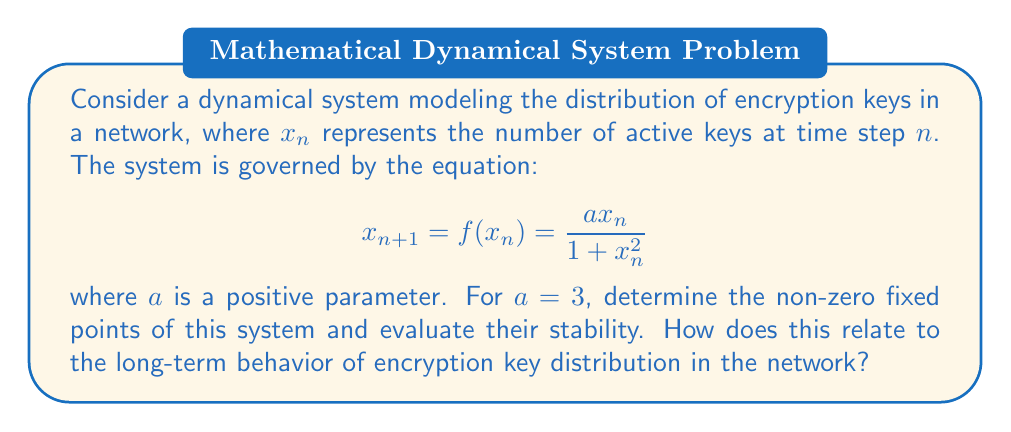Solve this math problem. 1. To find the fixed points, we solve the equation $x = f(x)$:

   $$x = \frac{3x}{1 + x^2}$$

2. Multiply both sides by $(1 + x^2)$:

   $$x(1 + x^2) = 3x$$
   $$x + x^3 = 3x$$

3. Rearrange to standard form:

   $$x^3 - 2x = 0$$
   $$x(x^2 - 2) = 0$$

4. Solve for x:

   $$x = 0$$ or $$x^2 = 2$$
   $$x = 0$$ or $$x = \pm\sqrt{2}$$

5. The non-zero fixed points are $x = \sqrt{2}$ and $x = -\sqrt{2}$.

6. To determine stability, we calculate $f'(x)$:

   $$f'(x) = \frac{a(1 + x^2) - ax(2x)}{(1 + x^2)^2} = \frac{a(1 - x^2)}{(1 + x^2)^2}$$

7. Evaluate $f'(x)$ at the fixed points:

   $$f'(\sqrt{2}) = f'(-\sqrt{2}) = \frac{3(1 - 2)}{(1 + 2)^2} = -\frac{1}{3}$$

8. Since $|f'(\sqrt{2})| < 1$ and $|f'(-\sqrt{2})| < 1$, both non-zero fixed points are stable.

9. This implies that the system will converge to one of these fixed points, representing a stable number of active encryption keys in the long term.

10. For an IT manager concerned with security, this suggests that the key distribution system will naturally tend towards a stable state, reducing the need for frequent manual interventions that might compromise security.
Answer: Non-zero fixed points: $\pm\sqrt{2}$; both stable. System converges to a stable number of active keys. 